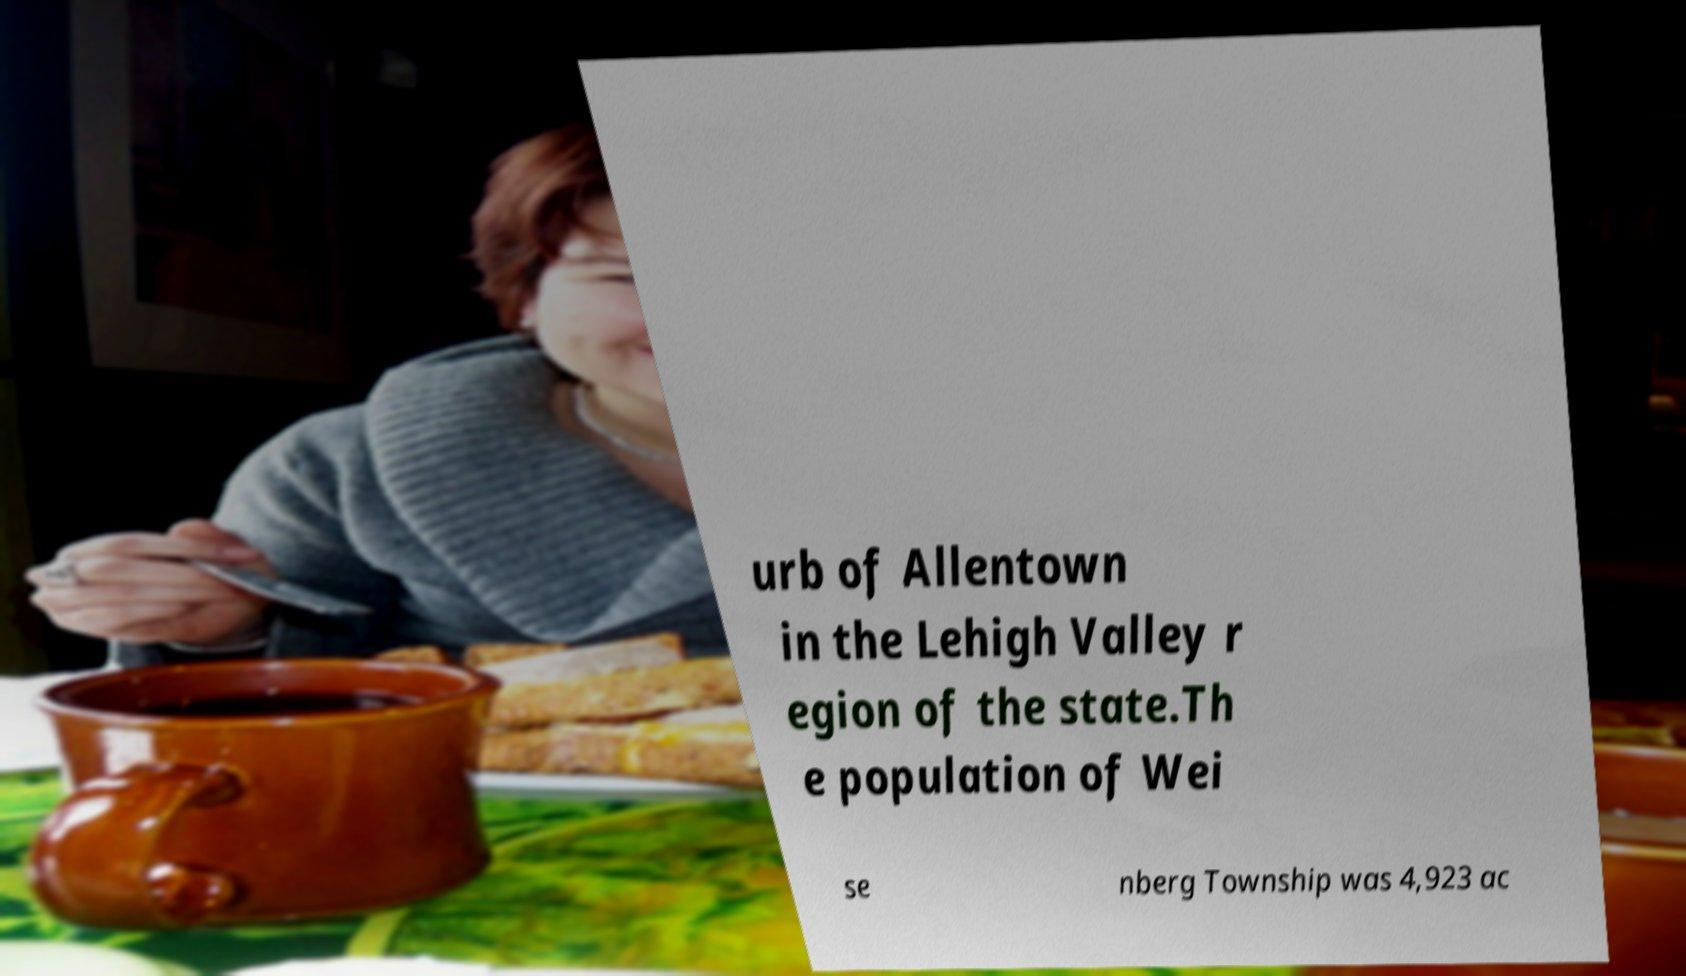Can you read and provide the text displayed in the image?This photo seems to have some interesting text. Can you extract and type it out for me? urb of Allentown in the Lehigh Valley r egion of the state.Th e population of Wei se nberg Township was 4,923 ac 